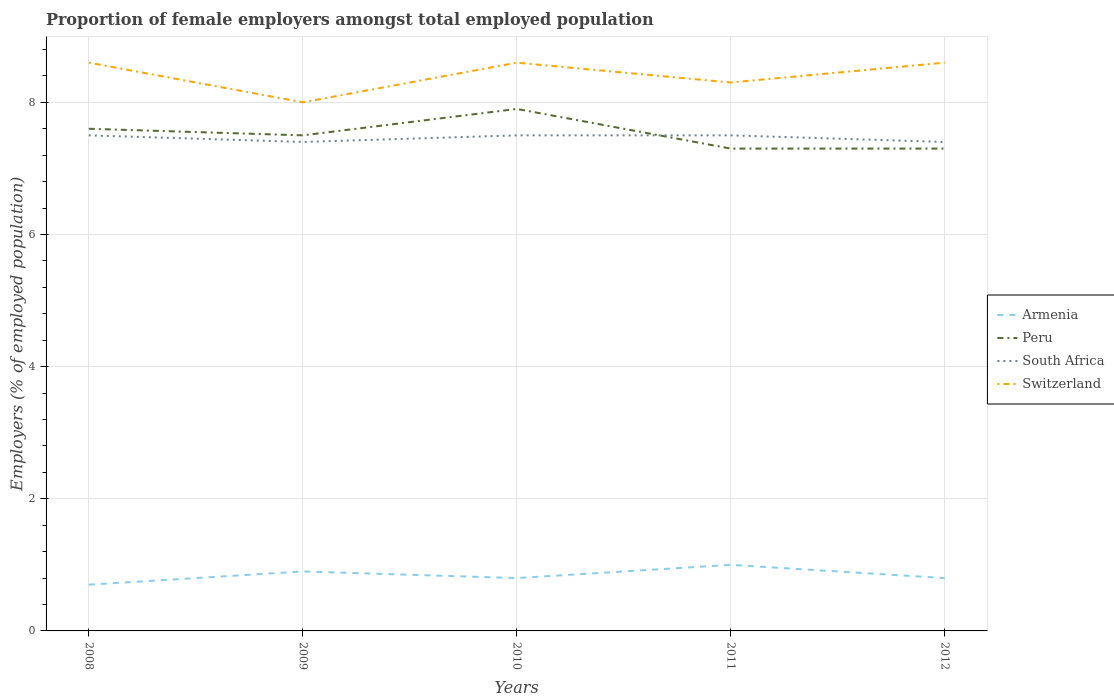Does the line corresponding to Peru intersect with the line corresponding to Switzerland?
Your answer should be very brief. No. Across all years, what is the maximum proportion of female employers in South Africa?
Keep it short and to the point. 7.4. What is the total proportion of female employers in Switzerland in the graph?
Offer a terse response. -0.6. What is the difference between the highest and the second highest proportion of female employers in South Africa?
Your answer should be very brief. 0.1. Is the proportion of female employers in South Africa strictly greater than the proportion of female employers in Peru over the years?
Keep it short and to the point. No. How many years are there in the graph?
Give a very brief answer. 5. Does the graph contain any zero values?
Provide a short and direct response. No. How are the legend labels stacked?
Make the answer very short. Vertical. What is the title of the graph?
Provide a short and direct response. Proportion of female employers amongst total employed population. Does "Lesotho" appear as one of the legend labels in the graph?
Offer a very short reply. No. What is the label or title of the Y-axis?
Keep it short and to the point. Employers (% of employed population). What is the Employers (% of employed population) of Armenia in 2008?
Make the answer very short. 0.7. What is the Employers (% of employed population) of Peru in 2008?
Provide a succinct answer. 7.6. What is the Employers (% of employed population) of Switzerland in 2008?
Provide a succinct answer. 8.6. What is the Employers (% of employed population) of Armenia in 2009?
Offer a very short reply. 0.9. What is the Employers (% of employed population) of South Africa in 2009?
Provide a short and direct response. 7.4. What is the Employers (% of employed population) in Switzerland in 2009?
Provide a succinct answer. 8. What is the Employers (% of employed population) in Armenia in 2010?
Your response must be concise. 0.8. What is the Employers (% of employed population) of Peru in 2010?
Your response must be concise. 7.9. What is the Employers (% of employed population) in Switzerland in 2010?
Make the answer very short. 8.6. What is the Employers (% of employed population) in Peru in 2011?
Offer a very short reply. 7.3. What is the Employers (% of employed population) in South Africa in 2011?
Provide a succinct answer. 7.5. What is the Employers (% of employed population) in Switzerland in 2011?
Your answer should be compact. 8.3. What is the Employers (% of employed population) in Armenia in 2012?
Your response must be concise. 0.8. What is the Employers (% of employed population) of Peru in 2012?
Offer a terse response. 7.3. What is the Employers (% of employed population) of South Africa in 2012?
Make the answer very short. 7.4. What is the Employers (% of employed population) of Switzerland in 2012?
Ensure brevity in your answer.  8.6. Across all years, what is the maximum Employers (% of employed population) in Armenia?
Your answer should be very brief. 1. Across all years, what is the maximum Employers (% of employed population) in Peru?
Provide a short and direct response. 7.9. Across all years, what is the maximum Employers (% of employed population) of Switzerland?
Provide a succinct answer. 8.6. Across all years, what is the minimum Employers (% of employed population) in Armenia?
Provide a succinct answer. 0.7. Across all years, what is the minimum Employers (% of employed population) of Peru?
Offer a very short reply. 7.3. Across all years, what is the minimum Employers (% of employed population) in South Africa?
Your answer should be very brief. 7.4. What is the total Employers (% of employed population) in Peru in the graph?
Give a very brief answer. 37.6. What is the total Employers (% of employed population) of South Africa in the graph?
Offer a very short reply. 37.3. What is the total Employers (% of employed population) of Switzerland in the graph?
Your response must be concise. 42.1. What is the difference between the Employers (% of employed population) in Armenia in 2008 and that in 2009?
Provide a succinct answer. -0.2. What is the difference between the Employers (% of employed population) of Peru in 2008 and that in 2009?
Give a very brief answer. 0.1. What is the difference between the Employers (% of employed population) in Switzerland in 2008 and that in 2009?
Offer a terse response. 0.6. What is the difference between the Employers (% of employed population) of Armenia in 2008 and that in 2010?
Your answer should be very brief. -0.1. What is the difference between the Employers (% of employed population) in Switzerland in 2008 and that in 2010?
Offer a very short reply. 0. What is the difference between the Employers (% of employed population) in Armenia in 2008 and that in 2011?
Keep it short and to the point. -0.3. What is the difference between the Employers (% of employed population) of Peru in 2008 and that in 2011?
Ensure brevity in your answer.  0.3. What is the difference between the Employers (% of employed population) of South Africa in 2008 and that in 2011?
Your answer should be very brief. 0. What is the difference between the Employers (% of employed population) of South Africa in 2009 and that in 2010?
Give a very brief answer. -0.1. What is the difference between the Employers (% of employed population) of South Africa in 2009 and that in 2011?
Your response must be concise. -0.1. What is the difference between the Employers (% of employed population) of South Africa in 2009 and that in 2012?
Ensure brevity in your answer.  0. What is the difference between the Employers (% of employed population) of Armenia in 2010 and that in 2011?
Offer a very short reply. -0.2. What is the difference between the Employers (% of employed population) of Peru in 2010 and that in 2011?
Ensure brevity in your answer.  0.6. What is the difference between the Employers (% of employed population) in Peru in 2010 and that in 2012?
Your response must be concise. 0.6. What is the difference between the Employers (% of employed population) in South Africa in 2010 and that in 2012?
Offer a very short reply. 0.1. What is the difference between the Employers (% of employed population) of Armenia in 2011 and that in 2012?
Make the answer very short. 0.2. What is the difference between the Employers (% of employed population) in Peru in 2011 and that in 2012?
Make the answer very short. 0. What is the difference between the Employers (% of employed population) of South Africa in 2011 and that in 2012?
Ensure brevity in your answer.  0.1. What is the difference between the Employers (% of employed population) of Switzerland in 2011 and that in 2012?
Your answer should be compact. -0.3. What is the difference between the Employers (% of employed population) of Armenia in 2008 and the Employers (% of employed population) of South Africa in 2009?
Provide a short and direct response. -6.7. What is the difference between the Employers (% of employed population) of Peru in 2008 and the Employers (% of employed population) of South Africa in 2009?
Provide a succinct answer. 0.2. What is the difference between the Employers (% of employed population) of Armenia in 2008 and the Employers (% of employed population) of South Africa in 2010?
Provide a succinct answer. -6.8. What is the difference between the Employers (% of employed population) of Peru in 2008 and the Employers (% of employed population) of Switzerland in 2010?
Ensure brevity in your answer.  -1. What is the difference between the Employers (% of employed population) of Armenia in 2008 and the Employers (% of employed population) of South Africa in 2011?
Your response must be concise. -6.8. What is the difference between the Employers (% of employed population) of Peru in 2008 and the Employers (% of employed population) of South Africa in 2011?
Your answer should be compact. 0.1. What is the difference between the Employers (% of employed population) of Peru in 2008 and the Employers (% of employed population) of Switzerland in 2011?
Offer a very short reply. -0.7. What is the difference between the Employers (% of employed population) of Armenia in 2008 and the Employers (% of employed population) of Peru in 2012?
Give a very brief answer. -6.6. What is the difference between the Employers (% of employed population) of Armenia in 2008 and the Employers (% of employed population) of South Africa in 2012?
Ensure brevity in your answer.  -6.7. What is the difference between the Employers (% of employed population) of Armenia in 2008 and the Employers (% of employed population) of Switzerland in 2012?
Give a very brief answer. -7.9. What is the difference between the Employers (% of employed population) in Peru in 2008 and the Employers (% of employed population) in Switzerland in 2012?
Provide a short and direct response. -1. What is the difference between the Employers (% of employed population) in South Africa in 2008 and the Employers (% of employed population) in Switzerland in 2012?
Provide a short and direct response. -1.1. What is the difference between the Employers (% of employed population) in Peru in 2009 and the Employers (% of employed population) in South Africa in 2010?
Ensure brevity in your answer.  0. What is the difference between the Employers (% of employed population) in South Africa in 2009 and the Employers (% of employed population) in Switzerland in 2010?
Give a very brief answer. -1.2. What is the difference between the Employers (% of employed population) of Armenia in 2009 and the Employers (% of employed population) of South Africa in 2011?
Make the answer very short. -6.6. What is the difference between the Employers (% of employed population) in Peru in 2009 and the Employers (% of employed population) in South Africa in 2011?
Ensure brevity in your answer.  0. What is the difference between the Employers (% of employed population) in South Africa in 2009 and the Employers (% of employed population) in Switzerland in 2011?
Your answer should be very brief. -0.9. What is the difference between the Employers (% of employed population) of Armenia in 2009 and the Employers (% of employed population) of Peru in 2012?
Give a very brief answer. -6.4. What is the difference between the Employers (% of employed population) in Armenia in 2009 and the Employers (% of employed population) in South Africa in 2012?
Offer a terse response. -6.5. What is the difference between the Employers (% of employed population) of Peru in 2009 and the Employers (% of employed population) of Switzerland in 2012?
Make the answer very short. -1.1. What is the difference between the Employers (% of employed population) of South Africa in 2009 and the Employers (% of employed population) of Switzerland in 2012?
Ensure brevity in your answer.  -1.2. What is the difference between the Employers (% of employed population) of Armenia in 2010 and the Employers (% of employed population) of Switzerland in 2011?
Provide a succinct answer. -7.5. What is the difference between the Employers (% of employed population) in Peru in 2010 and the Employers (% of employed population) in South Africa in 2011?
Your answer should be very brief. 0.4. What is the difference between the Employers (% of employed population) in South Africa in 2010 and the Employers (% of employed population) in Switzerland in 2011?
Provide a succinct answer. -0.8. What is the difference between the Employers (% of employed population) in Armenia in 2010 and the Employers (% of employed population) in Peru in 2012?
Offer a very short reply. -6.5. What is the difference between the Employers (% of employed population) in Armenia in 2010 and the Employers (% of employed population) in South Africa in 2012?
Your answer should be compact. -6.6. What is the difference between the Employers (% of employed population) in Armenia in 2010 and the Employers (% of employed population) in Switzerland in 2012?
Make the answer very short. -7.8. What is the difference between the Employers (% of employed population) in Peru in 2010 and the Employers (% of employed population) in South Africa in 2012?
Make the answer very short. 0.5. What is the difference between the Employers (% of employed population) in South Africa in 2010 and the Employers (% of employed population) in Switzerland in 2012?
Keep it short and to the point. -1.1. What is the difference between the Employers (% of employed population) of Armenia in 2011 and the Employers (% of employed population) of Peru in 2012?
Provide a succinct answer. -6.3. What is the difference between the Employers (% of employed population) of South Africa in 2011 and the Employers (% of employed population) of Switzerland in 2012?
Offer a very short reply. -1.1. What is the average Employers (% of employed population) in Armenia per year?
Provide a short and direct response. 0.84. What is the average Employers (% of employed population) in Peru per year?
Keep it short and to the point. 7.52. What is the average Employers (% of employed population) in South Africa per year?
Provide a succinct answer. 7.46. What is the average Employers (% of employed population) of Switzerland per year?
Provide a short and direct response. 8.42. In the year 2008, what is the difference between the Employers (% of employed population) in Armenia and Employers (% of employed population) in Peru?
Ensure brevity in your answer.  -6.9. In the year 2008, what is the difference between the Employers (% of employed population) of Armenia and Employers (% of employed population) of South Africa?
Your answer should be very brief. -6.8. In the year 2008, what is the difference between the Employers (% of employed population) of Armenia and Employers (% of employed population) of Switzerland?
Keep it short and to the point. -7.9. In the year 2008, what is the difference between the Employers (% of employed population) in Peru and Employers (% of employed population) in Switzerland?
Keep it short and to the point. -1. In the year 2008, what is the difference between the Employers (% of employed population) of South Africa and Employers (% of employed population) of Switzerland?
Your answer should be very brief. -1.1. In the year 2009, what is the difference between the Employers (% of employed population) in Armenia and Employers (% of employed population) in South Africa?
Give a very brief answer. -6.5. In the year 2009, what is the difference between the Employers (% of employed population) in Peru and Employers (% of employed population) in South Africa?
Offer a terse response. 0.1. In the year 2009, what is the difference between the Employers (% of employed population) in Peru and Employers (% of employed population) in Switzerland?
Your answer should be very brief. -0.5. In the year 2010, what is the difference between the Employers (% of employed population) of Armenia and Employers (% of employed population) of South Africa?
Your answer should be very brief. -6.7. In the year 2010, what is the difference between the Employers (% of employed population) of Armenia and Employers (% of employed population) of Switzerland?
Keep it short and to the point. -7.8. In the year 2010, what is the difference between the Employers (% of employed population) of Peru and Employers (% of employed population) of South Africa?
Offer a terse response. 0.4. In the year 2010, what is the difference between the Employers (% of employed population) in Peru and Employers (% of employed population) in Switzerland?
Offer a terse response. -0.7. In the year 2010, what is the difference between the Employers (% of employed population) of South Africa and Employers (% of employed population) of Switzerland?
Offer a terse response. -1.1. In the year 2012, what is the difference between the Employers (% of employed population) of Armenia and Employers (% of employed population) of Peru?
Ensure brevity in your answer.  -6.5. In the year 2012, what is the difference between the Employers (% of employed population) of Armenia and Employers (% of employed population) of South Africa?
Offer a very short reply. -6.6. In the year 2012, what is the difference between the Employers (% of employed population) of Armenia and Employers (% of employed population) of Switzerland?
Ensure brevity in your answer.  -7.8. In the year 2012, what is the difference between the Employers (% of employed population) of Peru and Employers (% of employed population) of Switzerland?
Give a very brief answer. -1.3. What is the ratio of the Employers (% of employed population) in Armenia in 2008 to that in 2009?
Offer a very short reply. 0.78. What is the ratio of the Employers (% of employed population) of Peru in 2008 to that in 2009?
Ensure brevity in your answer.  1.01. What is the ratio of the Employers (% of employed population) in South Africa in 2008 to that in 2009?
Ensure brevity in your answer.  1.01. What is the ratio of the Employers (% of employed population) in Switzerland in 2008 to that in 2009?
Provide a short and direct response. 1.07. What is the ratio of the Employers (% of employed population) in Armenia in 2008 to that in 2010?
Your answer should be compact. 0.88. What is the ratio of the Employers (% of employed population) in Peru in 2008 to that in 2010?
Your answer should be very brief. 0.96. What is the ratio of the Employers (% of employed population) of Switzerland in 2008 to that in 2010?
Ensure brevity in your answer.  1. What is the ratio of the Employers (% of employed population) of Peru in 2008 to that in 2011?
Offer a terse response. 1.04. What is the ratio of the Employers (% of employed population) in South Africa in 2008 to that in 2011?
Provide a succinct answer. 1. What is the ratio of the Employers (% of employed population) in Switzerland in 2008 to that in 2011?
Provide a short and direct response. 1.04. What is the ratio of the Employers (% of employed population) in Armenia in 2008 to that in 2012?
Keep it short and to the point. 0.88. What is the ratio of the Employers (% of employed population) in Peru in 2008 to that in 2012?
Offer a terse response. 1.04. What is the ratio of the Employers (% of employed population) in South Africa in 2008 to that in 2012?
Provide a succinct answer. 1.01. What is the ratio of the Employers (% of employed population) in Armenia in 2009 to that in 2010?
Give a very brief answer. 1.12. What is the ratio of the Employers (% of employed population) of Peru in 2009 to that in 2010?
Offer a terse response. 0.95. What is the ratio of the Employers (% of employed population) in South Africa in 2009 to that in 2010?
Offer a terse response. 0.99. What is the ratio of the Employers (% of employed population) of Switzerland in 2009 to that in 2010?
Give a very brief answer. 0.93. What is the ratio of the Employers (% of employed population) of Peru in 2009 to that in 2011?
Provide a succinct answer. 1.03. What is the ratio of the Employers (% of employed population) of South Africa in 2009 to that in 2011?
Ensure brevity in your answer.  0.99. What is the ratio of the Employers (% of employed population) in Switzerland in 2009 to that in 2011?
Provide a succinct answer. 0.96. What is the ratio of the Employers (% of employed population) in Armenia in 2009 to that in 2012?
Make the answer very short. 1.12. What is the ratio of the Employers (% of employed population) of Peru in 2009 to that in 2012?
Provide a succinct answer. 1.03. What is the ratio of the Employers (% of employed population) in Switzerland in 2009 to that in 2012?
Offer a terse response. 0.93. What is the ratio of the Employers (% of employed population) of Peru in 2010 to that in 2011?
Give a very brief answer. 1.08. What is the ratio of the Employers (% of employed population) of Switzerland in 2010 to that in 2011?
Provide a short and direct response. 1.04. What is the ratio of the Employers (% of employed population) of Peru in 2010 to that in 2012?
Keep it short and to the point. 1.08. What is the ratio of the Employers (% of employed population) in South Africa in 2010 to that in 2012?
Your response must be concise. 1.01. What is the ratio of the Employers (% of employed population) in Switzerland in 2010 to that in 2012?
Ensure brevity in your answer.  1. What is the ratio of the Employers (% of employed population) in Armenia in 2011 to that in 2012?
Offer a terse response. 1.25. What is the ratio of the Employers (% of employed population) in Peru in 2011 to that in 2012?
Make the answer very short. 1. What is the ratio of the Employers (% of employed population) of South Africa in 2011 to that in 2012?
Offer a terse response. 1.01. What is the ratio of the Employers (% of employed population) in Switzerland in 2011 to that in 2012?
Your answer should be compact. 0.97. What is the difference between the highest and the second highest Employers (% of employed population) of Armenia?
Offer a terse response. 0.1. What is the difference between the highest and the second highest Employers (% of employed population) of Peru?
Provide a short and direct response. 0.3. What is the difference between the highest and the lowest Employers (% of employed population) in Armenia?
Give a very brief answer. 0.3. What is the difference between the highest and the lowest Employers (% of employed population) of South Africa?
Provide a short and direct response. 0.1. What is the difference between the highest and the lowest Employers (% of employed population) in Switzerland?
Offer a terse response. 0.6. 